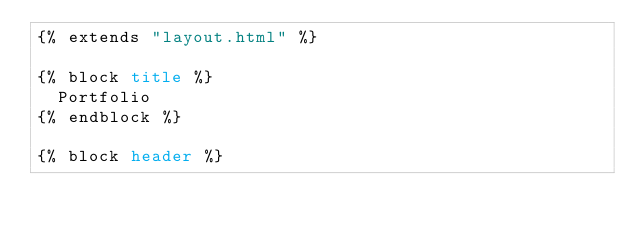<code> <loc_0><loc_0><loc_500><loc_500><_HTML_>{% extends "layout.html" %}

{% block title %}
	Portfolio
{% endblock %}

{% block header %}</code> 